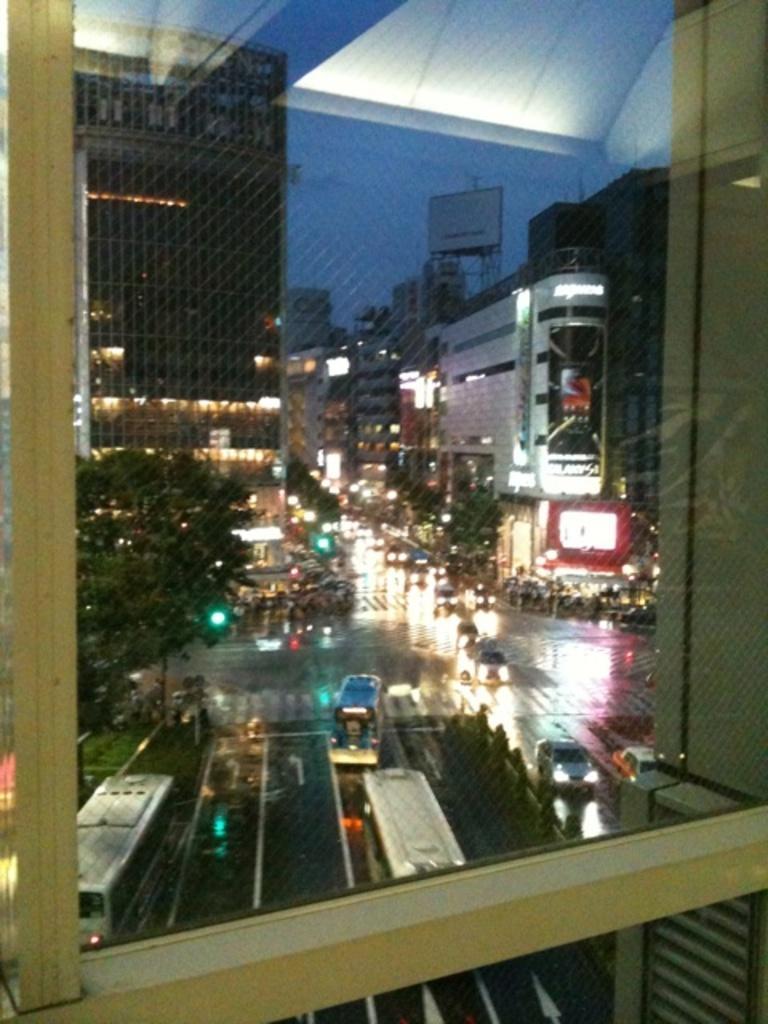Describe this image in one or two sentences. In this picture we can see vehicles on the road, trees, buildings, lights and in the background we can see the sky. 